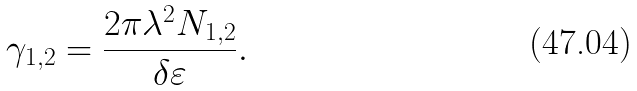Convert formula to latex. <formula><loc_0><loc_0><loc_500><loc_500>\gamma _ { 1 , 2 } = \frac { 2 \pi \lambda ^ { 2 } N _ { 1 , 2 } } { \delta \varepsilon } .</formula> 